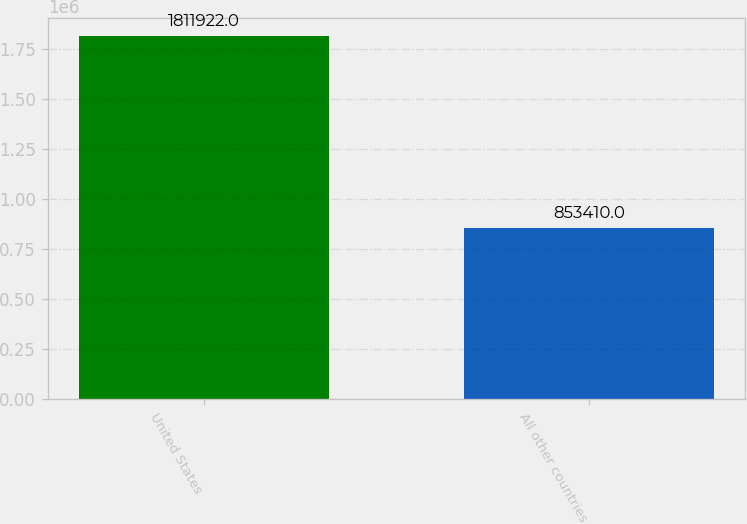Convert chart to OTSL. <chart><loc_0><loc_0><loc_500><loc_500><bar_chart><fcel>United States<fcel>All other countries<nl><fcel>1.81192e+06<fcel>853410<nl></chart> 